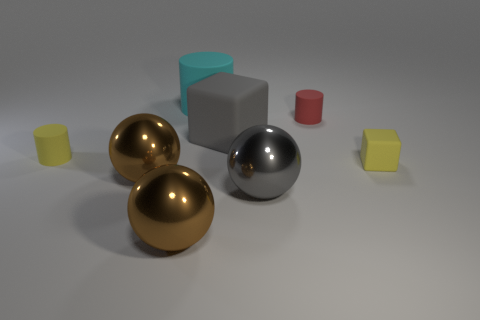There is another tiny thing that is the same shape as the tiny red rubber thing; what is it made of?
Provide a short and direct response. Rubber. What number of balls are either big brown objects or large gray metallic things?
Your response must be concise. 3. Are any tiny purple matte things visible?
Your response must be concise. No. What number of other things are the same material as the small yellow cylinder?
Provide a succinct answer. 4. There is a gray ball that is the same size as the cyan rubber object; what is its material?
Ensure brevity in your answer.  Metal. Do the yellow object that is on the right side of the cyan matte object and the large gray rubber thing have the same shape?
Make the answer very short. Yes. How many things are either gray objects that are in front of the large block or cyan metal objects?
Provide a short and direct response. 1. What shape is the yellow object that is the same size as the yellow matte cylinder?
Keep it short and to the point. Cube. There is a matte cylinder in front of the small red rubber thing; does it have the same size as the metallic ball that is behind the gray metal object?
Make the answer very short. No. What is the color of the big cube that is made of the same material as the tiny yellow cube?
Your answer should be compact. Gray. 